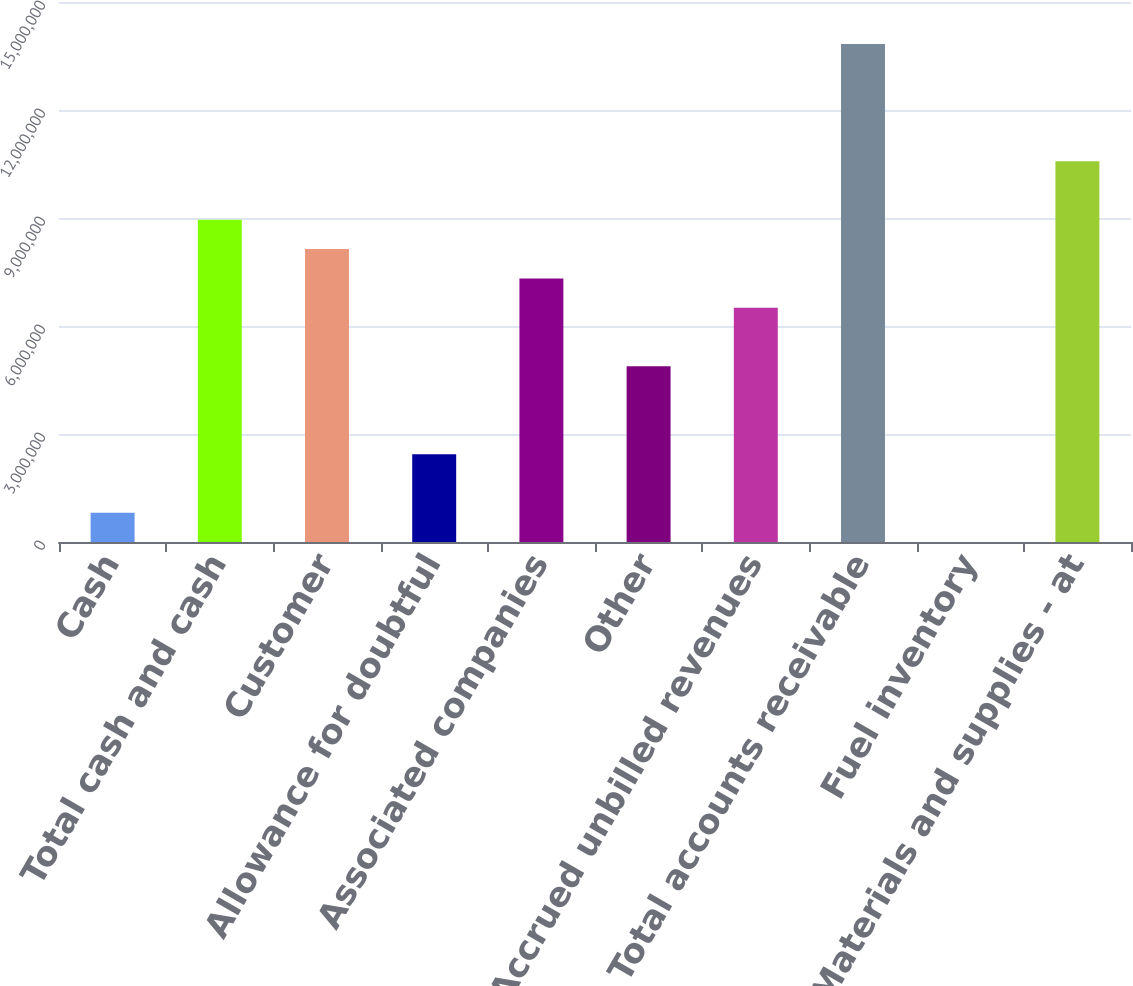Convert chart to OTSL. <chart><loc_0><loc_0><loc_500><loc_500><bar_chart><fcel>Cash<fcel>Total cash and cash<fcel>Customer<fcel>Allowance for doubtful<fcel>Associated companies<fcel>Other<fcel>Accrued unbilled revenues<fcel>Total accounts receivable<fcel>Fuel inventory<fcel>Materials and supplies - at<nl><fcel>813614<fcel>8.94972e+06<fcel>8.13611e+06<fcel>2.44084e+06<fcel>7.3225e+06<fcel>4.88167e+06<fcel>6.50889e+06<fcel>1.38314e+07<fcel>3<fcel>1.05769e+07<nl></chart> 